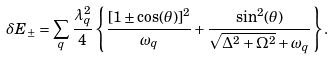Convert formula to latex. <formula><loc_0><loc_0><loc_500><loc_500>\delta E _ { \pm } = \sum _ { q } \frac { \lambda _ { q } ^ { 2 } } { 4 } \left \{ \frac { [ 1 \pm \cos ( \theta ) ] ^ { 2 } } { \omega _ { q } } + \frac { \sin ^ { 2 } ( \theta ) } { \sqrt { \Delta ^ { 2 } + \Omega ^ { 2 } } + \omega _ { q } } \right \} .</formula> 